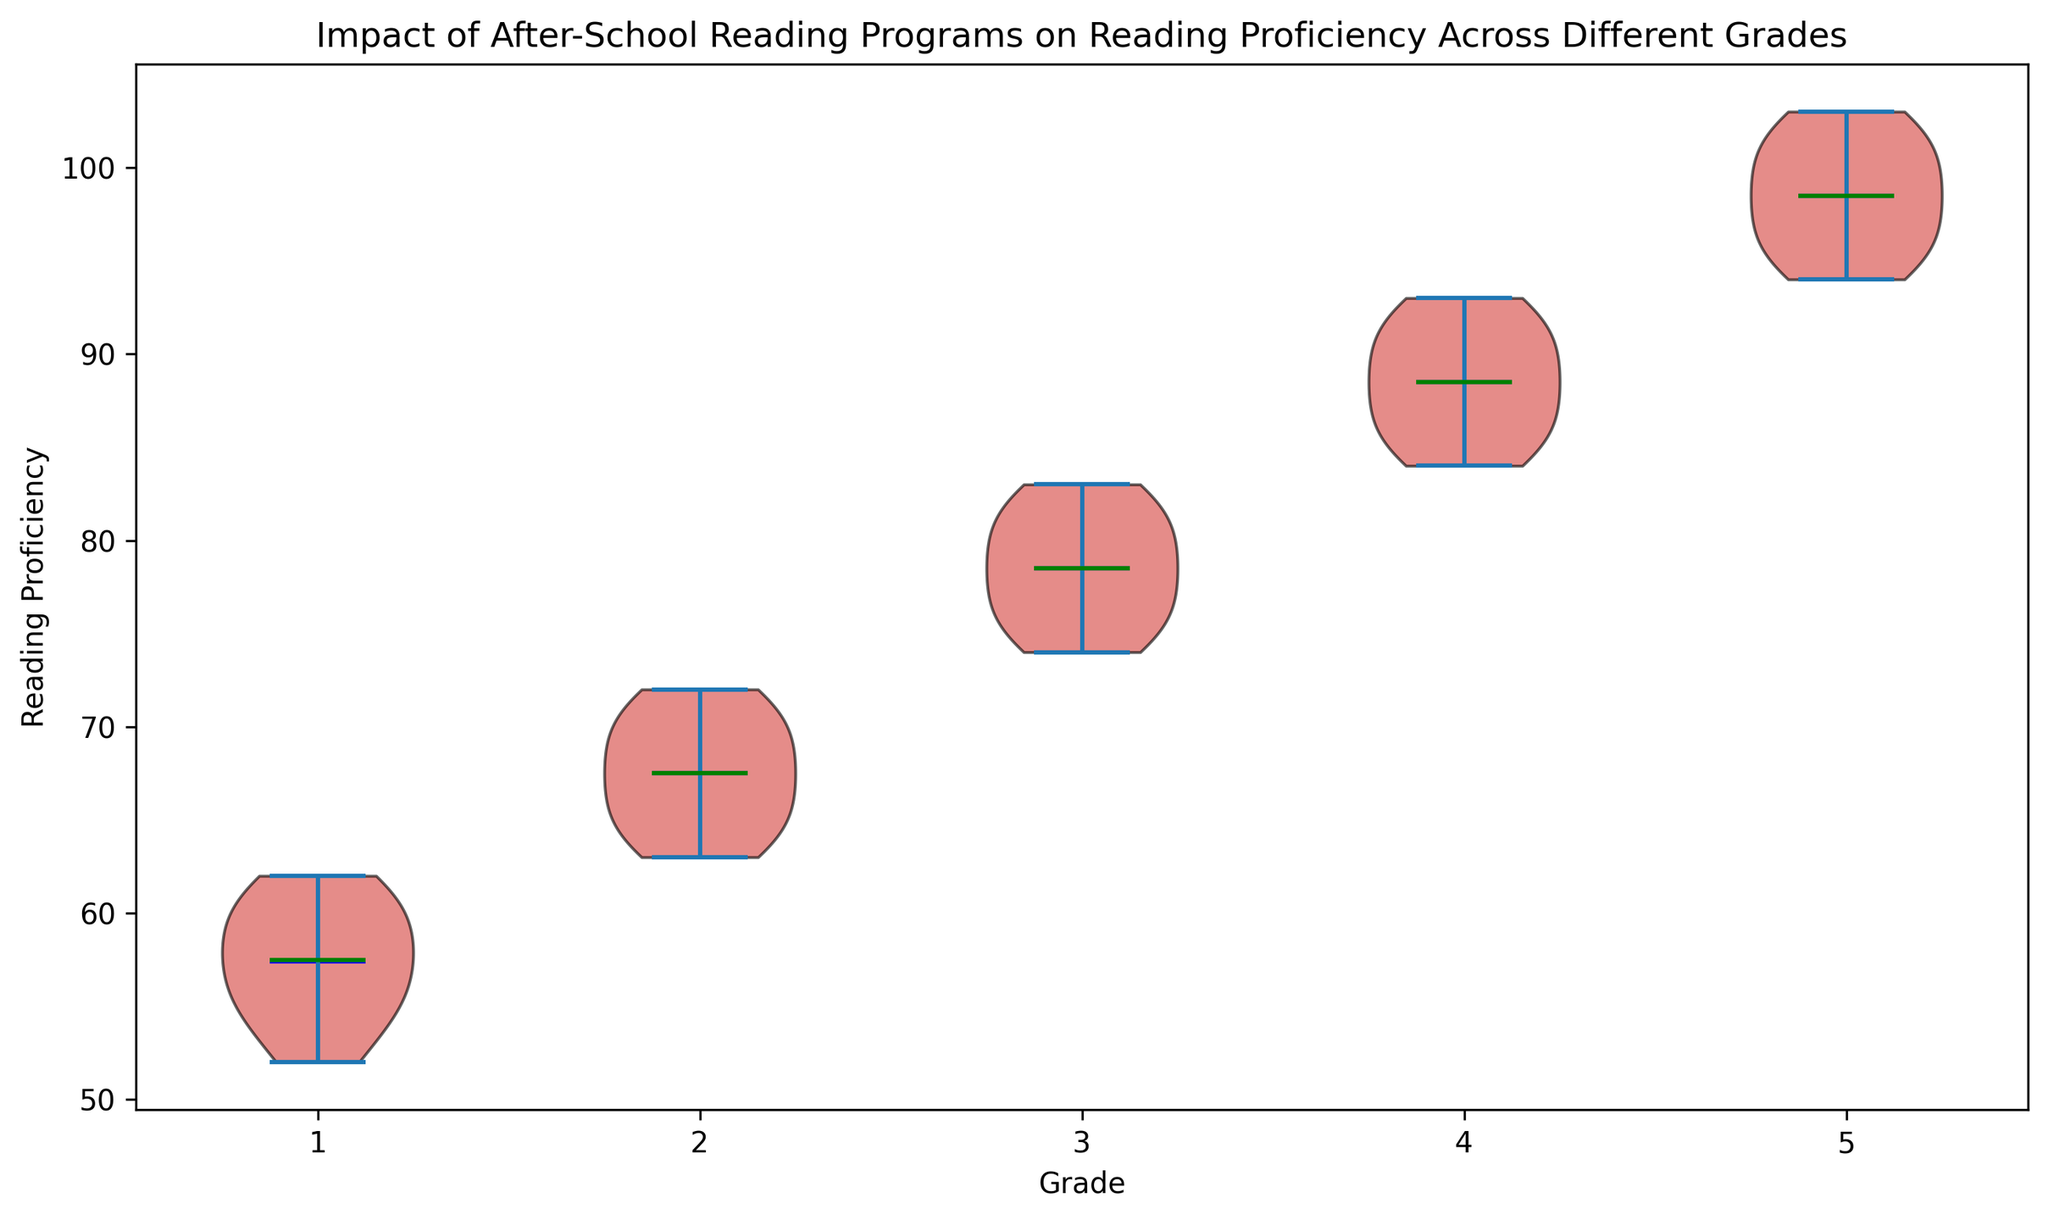Which grade has the highest median reading proficiency? By observing the green medians in each violin plot, we can identify the tallest green line. The tallest green line is associated with grade 5.
Answer: Grade 5 What is the average reading proficiency for Grade 3? To calculate the average, sum up the reading proficiencies for Grade 3 and then divide by the number of data points. The values are 75, 77, 79, 81, 78, 76, 80, 82, 74, and 83. Summing these gives 785, and there are 10 points, so the average is 785/10.
Answer: 78.5 Which grade shows the widest range in reading proficiency? By looking at the spread of the violins, the grade with the widest range will have the largest vertical span. Grade 5 shows the widest range from approximately 94 to 103.
Answer: Grade 5 How does the mean reading proficiency of Grade 2 compare to Grade 4? The blue means in the violin plots represent the average reading proficiency. Comparing the heights of the blue lines in grades 2 and 4, we see that Grade 4 has a higher mean than Grade 2.
Answer: Grade 4 is higher than Grade 2 Which grade has the smallest spread in reading proficiency scores? The grade with the smallest spread will have the shortest vertical span in its violin plot. Grade 1 shows the smallest range, approximately from 52 to 62.
Answer: Grade 1 What is the range of reading proficiency for Grade 4? To find the range, subtract the smallest value in Grade 4 from the largest value. The maximum reading proficiency in Grade 4 is 93 and the minimum is 84. Therefore, the range is 93 - 84.
Answer: 9 Are the median and mean reading proficiencies for Grade 1 close to each other? The green line (median) and blue line (mean) in the Grade 1 violin plot are fairly close in height, indicating that the median and mean values are similar.
Answer: Yes Which grade shows the highest concentration of reading proficiency scores around the mean? This can be identified by observing the narrowest region of the violin plot around the blue mean line. Grade 5's violin plot is narrowest around its mean, indicating high concentration.
Answer: Grade 5 How does the interquartile range (IQR) of Grade 3 compare to Grade 2? The IQR is the range between the first quartile (25th percentile) and the third quartile (75th percentile). Comparing the vertical thickness of the middle parts of Grades 3 and 2, Grade 3 has a higher interquartile range.
Answer: Grade 3 is higher than Grade 2 What is the lowest reading proficiency score observed in Grade 2? The lowest point of Grade 2's violin plot represents the minimum value, which is around 63.
Answer: 63 